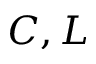Convert formula to latex. <formula><loc_0><loc_0><loc_500><loc_500>C , L</formula> 